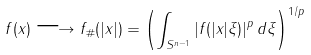<formula> <loc_0><loc_0><loc_500><loc_500>f ( x ) \longrightarrow f _ { \# } ( | x | ) = \left ( \int _ { S ^ { n - 1 } } | f ( | x | \xi ) | ^ { p } \, d \xi \right ) ^ { 1 / p }</formula> 